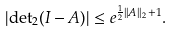<formula> <loc_0><loc_0><loc_500><loc_500>| { \det } _ { 2 } ( I - A ) | \leq e ^ { \frac { 1 } { 2 } | | A | | _ { 2 } + 1 } .</formula> 